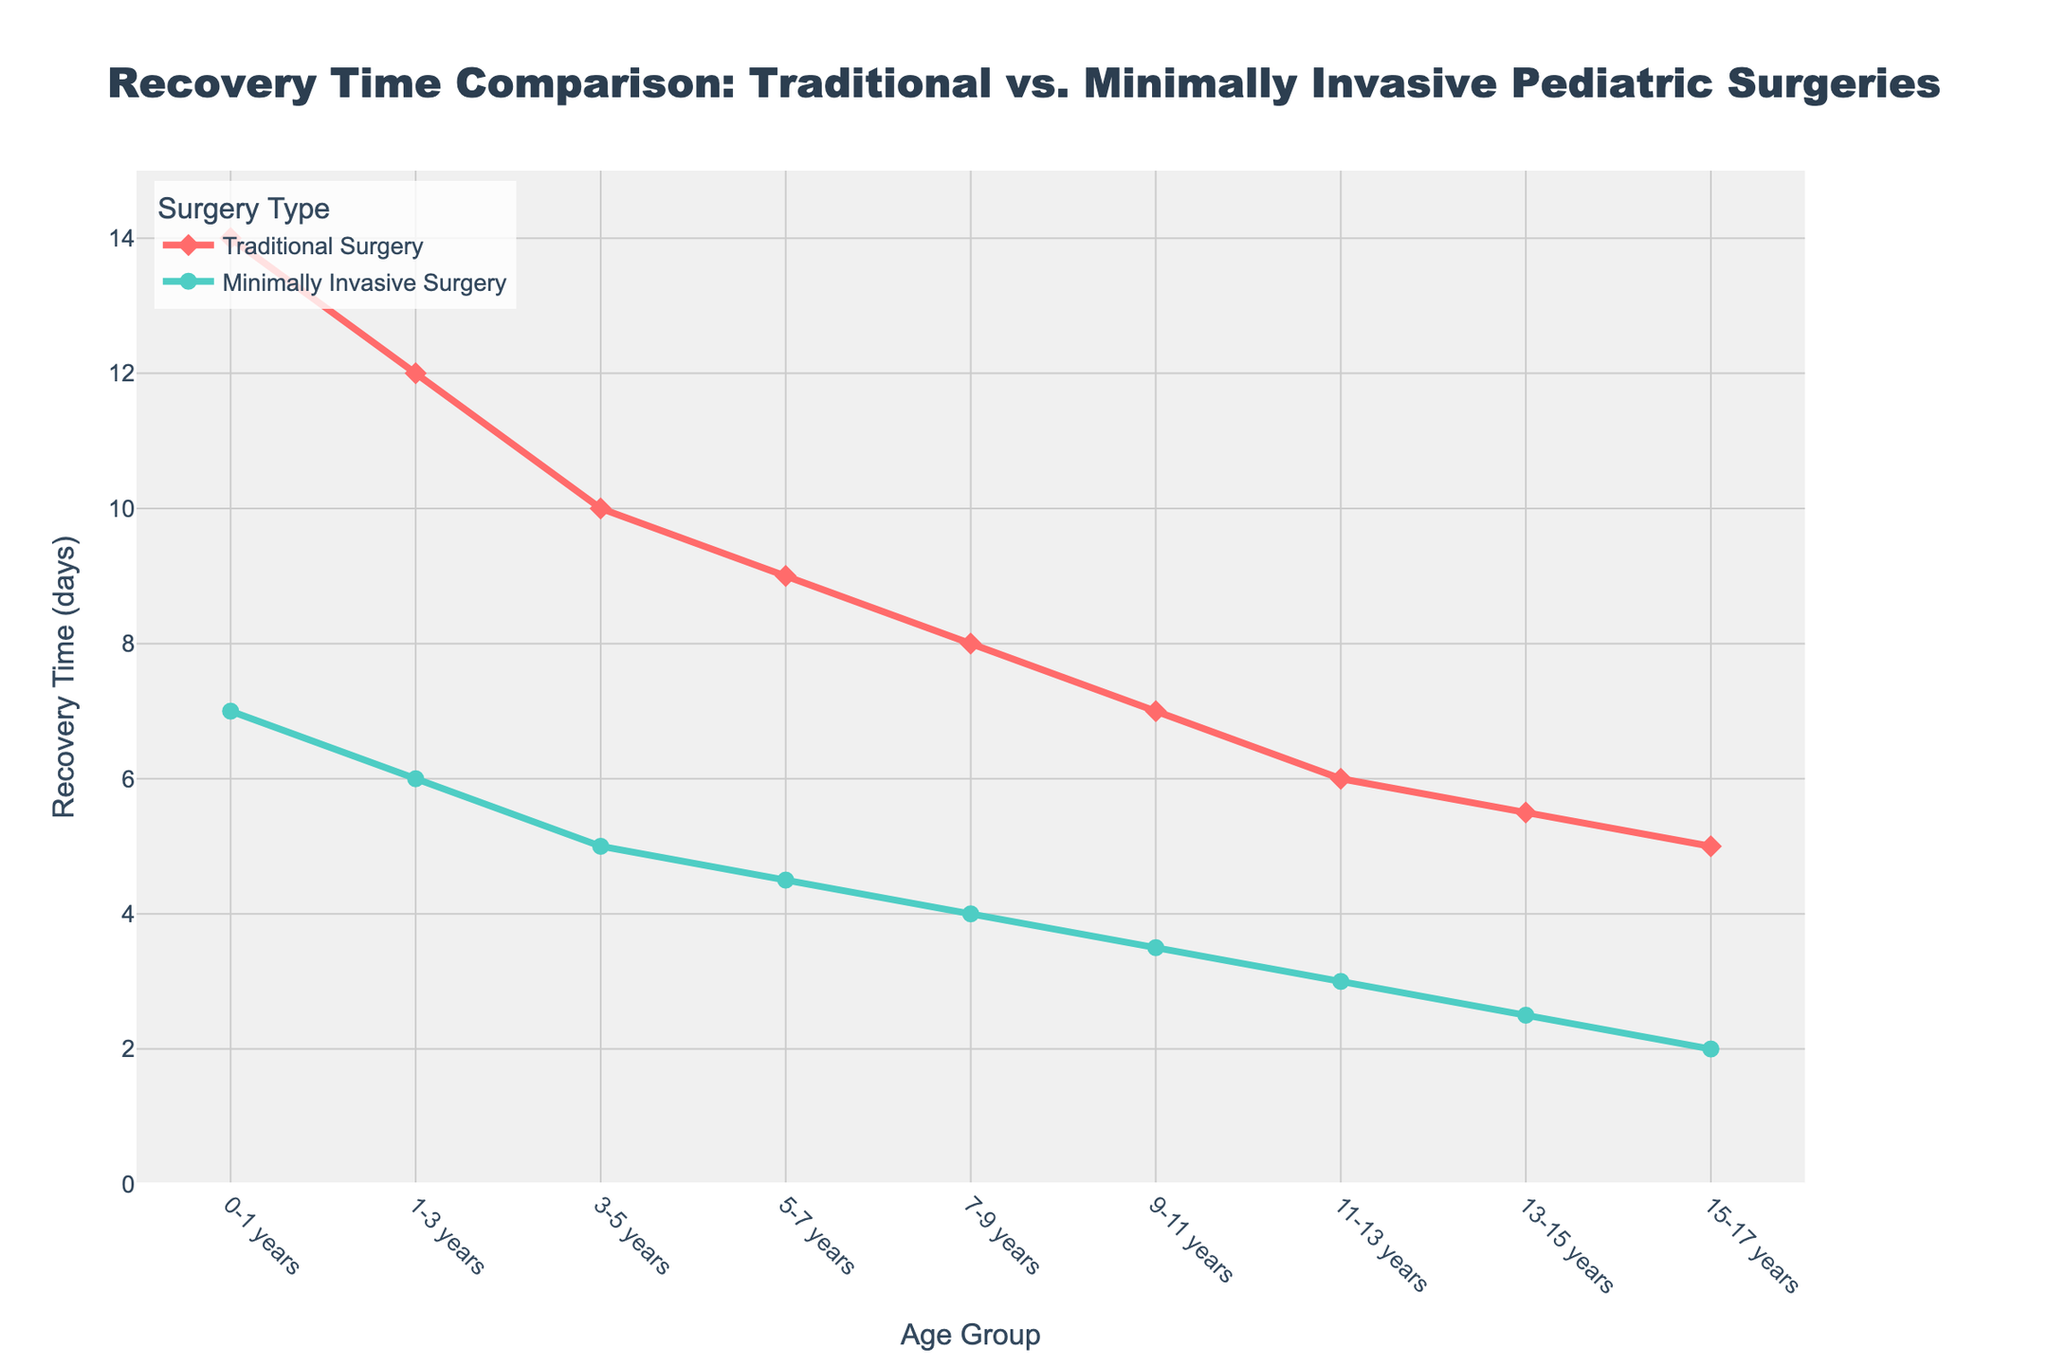What is the difference in recovery time for 0-1 years old between traditional and minimally invasive surgery? To find the difference in recovery time, subtract the recovery time of minimally invasive surgery from that of traditional surgery for the 0-1 years age group: 14 - 7 = 7 days.
Answer: 7 days Which age group has the smallest recovery time for traditional surgery? Among the age groups listed, the age group 15-17 years old has the smallest recovery time for traditional surgery which is 5 days.
Answer: 15-17 years For the 3-5 years age group, what is the percentage reduction in recovery time when comparing minimally invasive surgery to traditional surgery? Calculate the percentage reduction using the formula: ((Traditional - Minimally Invasive) / Traditional) * 100. For the 3-5 years group: ((10 - 5) / 10) * 100 = 50%.
Answer: 50% By how many days does the recovery time decrease for traditional surgery from age group 0-1 years to 11-13 years? Subtract the recovery time of the 11-13 years age group from the 0-1 years age group for traditional surgery: 14 - 6 = 8 days.
Answer: 8 days Which surgery type shows a consistent reduction across all age groups in the data? For both traditional and minimally invasive surgeries, the recovery time decreases consistently across age groups, but minimally invasive surgery shows a consistently steeper reduction.
Answer: Minimally invasive surgery What is the recovery time difference for the 9-11 years age group between the two types of surgeries? Subtract the recovery time of minimally invasive surgery from traditional surgery for the 9-11 years age group: 7 - 3.5 = 3.5 days.
Answer: 3.5 days Which surgery type has shorter recovery times for the age group 5-7 years? Minimally invasive surgery has shorter recovery times of 4.5 days compared to traditional surgery at 9 days for the 5-7 years age group.
Answer: Minimally invasive surgery By observing the lines' slopes, which surgery type has a steeper decline in recovery times across age groups? The minimally invasive surgery line has a visibly steeper slope compared to the traditional surgery line, indicating a faster reduction in recovery times across age groups.
Answer: Minimally invasive surgery 